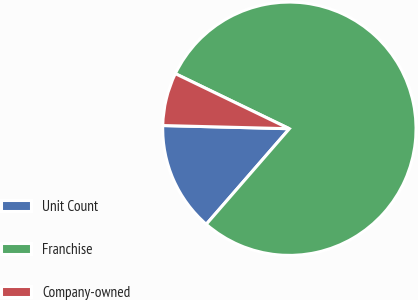Convert chart. <chart><loc_0><loc_0><loc_500><loc_500><pie_chart><fcel>Unit Count<fcel>Franchise<fcel>Company-owned<nl><fcel>14.01%<fcel>79.24%<fcel>6.76%<nl></chart> 